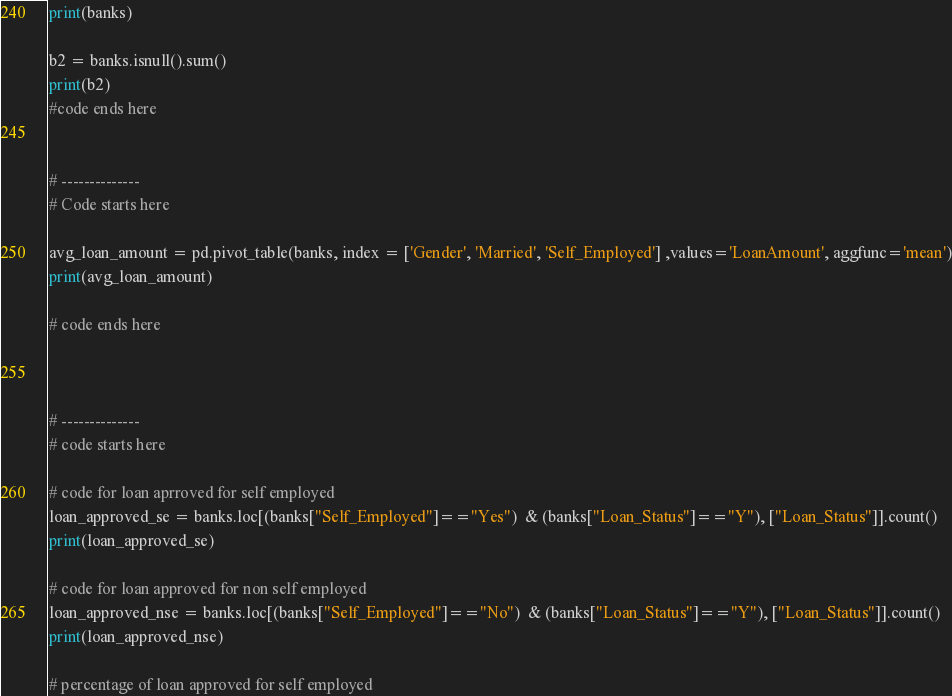<code> <loc_0><loc_0><loc_500><loc_500><_Python_>print(banks)

b2 = banks.isnull().sum()
print(b2)
#code ends here


# --------------
# Code starts here

avg_loan_amount = pd.pivot_table(banks, index = ['Gender', 'Married', 'Self_Employed'] ,values='LoanAmount', aggfunc='mean')
print(avg_loan_amount)

# code ends here



# --------------
# code starts here

# code for loan aprroved for self employed
loan_approved_se = banks.loc[(banks["Self_Employed"]=="Yes")  & (banks["Loan_Status"]=="Y"), ["Loan_Status"]].count()
print(loan_approved_se)

# code for loan approved for non self employed
loan_approved_nse = banks.loc[(banks["Self_Employed"]=="No")  & (banks["Loan_Status"]=="Y"), ["Loan_Status"]].count()
print(loan_approved_nse)

# percentage of loan approved for self employed</code> 